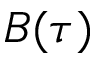<formula> <loc_0><loc_0><loc_500><loc_500>B ( \tau )</formula> 